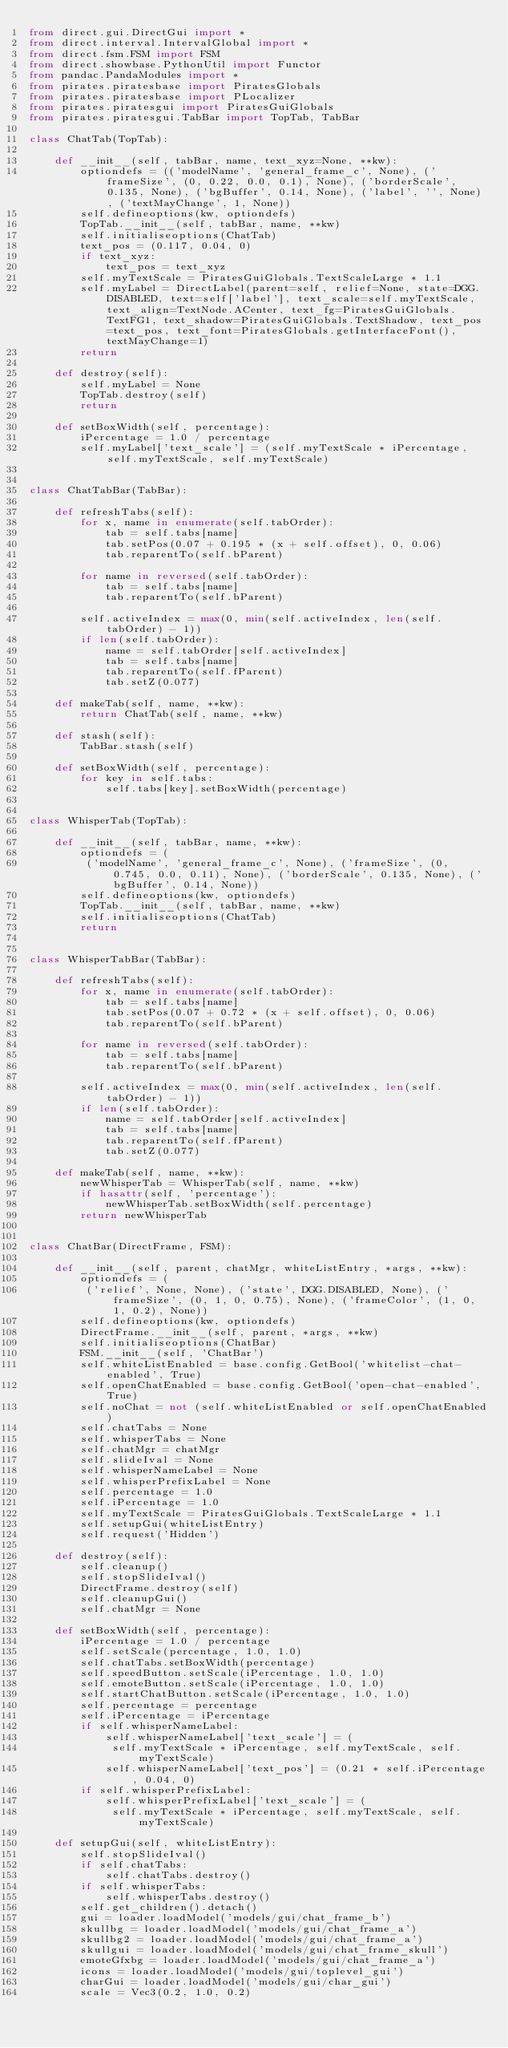<code> <loc_0><loc_0><loc_500><loc_500><_Python_>from direct.gui.DirectGui import *
from direct.interval.IntervalGlobal import *
from direct.fsm.FSM import FSM
from direct.showbase.PythonUtil import Functor
from pandac.PandaModules import *
from pirates.piratesbase import PiratesGlobals
from pirates.piratesbase import PLocalizer
from pirates.piratesgui import PiratesGuiGlobals
from pirates.piratesgui.TabBar import TopTab, TabBar

class ChatTab(TopTab):

    def __init__(self, tabBar, name, text_xyz=None, **kw):
        optiondefs = (('modelName', 'general_frame_c', None), ('frameSize', (0, 0.22, 0.0, 0.1), None), ('borderScale', 0.135, None), ('bgBuffer', 0.14, None), ('label', '', None), ('textMayChange', 1, None))
        self.defineoptions(kw, optiondefs)
        TopTab.__init__(self, tabBar, name, **kw)
        self.initialiseoptions(ChatTab)
        text_pos = (0.117, 0.04, 0)
        if text_xyz:
            text_pos = text_xyz
        self.myTextScale = PiratesGuiGlobals.TextScaleLarge * 1.1
        self.myLabel = DirectLabel(parent=self, relief=None, state=DGG.DISABLED, text=self['label'], text_scale=self.myTextScale, text_align=TextNode.ACenter, text_fg=PiratesGuiGlobals.TextFG1, text_shadow=PiratesGuiGlobals.TextShadow, text_pos=text_pos, text_font=PiratesGlobals.getInterfaceFont(), textMayChange=1)
        return

    def destroy(self):
        self.myLabel = None
        TopTab.destroy(self)
        return

    def setBoxWidth(self, percentage):
        iPercentage = 1.0 / percentage
        self.myLabel['text_scale'] = (self.myTextScale * iPercentage, self.myTextScale, self.myTextScale)


class ChatTabBar(TabBar):

    def refreshTabs(self):
        for x, name in enumerate(self.tabOrder):
            tab = self.tabs[name]
            tab.setPos(0.07 + 0.195 * (x + self.offset), 0, 0.06)
            tab.reparentTo(self.bParent)

        for name in reversed(self.tabOrder):
            tab = self.tabs[name]
            tab.reparentTo(self.bParent)

        self.activeIndex = max(0, min(self.activeIndex, len(self.tabOrder) - 1))
        if len(self.tabOrder):
            name = self.tabOrder[self.activeIndex]
            tab = self.tabs[name]
            tab.reparentTo(self.fParent)
            tab.setZ(0.077)

    def makeTab(self, name, **kw):
        return ChatTab(self, name, **kw)

    def stash(self):
        TabBar.stash(self)

    def setBoxWidth(self, percentage):
        for key in self.tabs:
            self.tabs[key].setBoxWidth(percentage)


class WhisperTab(TopTab):

    def __init__(self, tabBar, name, **kw):
        optiondefs = (
         ('modelName', 'general_frame_c', None), ('frameSize', (0, 0.745, 0.0, 0.11), None), ('borderScale', 0.135, None), ('bgBuffer', 0.14, None))
        self.defineoptions(kw, optiondefs)
        TopTab.__init__(self, tabBar, name, **kw)
        self.initialiseoptions(ChatTab)
        return


class WhisperTabBar(TabBar):

    def refreshTabs(self):
        for x, name in enumerate(self.tabOrder):
            tab = self.tabs[name]
            tab.setPos(0.07 + 0.72 * (x + self.offset), 0, 0.06)
            tab.reparentTo(self.bParent)

        for name in reversed(self.tabOrder):
            tab = self.tabs[name]
            tab.reparentTo(self.bParent)

        self.activeIndex = max(0, min(self.activeIndex, len(self.tabOrder) - 1))
        if len(self.tabOrder):
            name = self.tabOrder[self.activeIndex]
            tab = self.tabs[name]
            tab.reparentTo(self.fParent)
            tab.setZ(0.077)

    def makeTab(self, name, **kw):
        newWhisperTab = WhisperTab(self, name, **kw)
        if hasattr(self, 'percentage'):
            newWhisperTab.setBoxWidth(self.percentage)
        return newWhisperTab


class ChatBar(DirectFrame, FSM):

    def __init__(self, parent, chatMgr, whiteListEntry, *args, **kw):
        optiondefs = (
         ('relief', None, None), ('state', DGG.DISABLED, None), ('frameSize', (0, 1, 0, 0.75), None), ('frameColor', (1, 0, 1, 0.2), None))
        self.defineoptions(kw, optiondefs)
        DirectFrame.__init__(self, parent, *args, **kw)
        self.initialiseoptions(ChatBar)
        FSM.__init__(self, 'ChatBar')
        self.whiteListEnabled = base.config.GetBool('whitelist-chat-enabled', True)
        self.openChatEnabled = base.config.GetBool('open-chat-enabled', True)
        self.noChat = not (self.whiteListEnabled or self.openChatEnabled)
        self.chatTabs = None
        self.whisperTabs = None
        self.chatMgr = chatMgr
        self.slideIval = None
        self.whisperNameLabel = None
        self.whisperPrefixLabel = None
        self.percentage = 1.0
        self.iPercentage = 1.0
        self.myTextScale = PiratesGuiGlobals.TextScaleLarge * 1.1
        self.setupGui(whiteListEntry)
        self.request('Hidden')

    def destroy(self):
        self.cleanup()
        self.stopSlideIval()
        DirectFrame.destroy(self)
        self.cleanupGui()
        self.chatMgr = None

    def setBoxWidth(self, percentage):
        iPercentage = 1.0 / percentage
        self.setScale(percentage, 1.0, 1.0)
        self.chatTabs.setBoxWidth(percentage)
        self.speedButton.setScale(iPercentage, 1.0, 1.0)
        self.emoteButton.setScale(iPercentage, 1.0, 1.0)
        self.startChatButton.setScale(iPercentage, 1.0, 1.0)
        self.percentage = percentage
        self.iPercentage = iPercentage
        if self.whisperNameLabel:
            self.whisperNameLabel['text_scale'] = (
             self.myTextScale * iPercentage, self.myTextScale, self.myTextScale)
            self.whisperNameLabel['text_pos'] = (0.21 * self.iPercentage, 0.04, 0)
        if self.whisperPrefixLabel:
            self.whisperPrefixLabel['text_scale'] = (
             self.myTextScale * iPercentage, self.myTextScale, self.myTextScale)

    def setupGui(self, whiteListEntry):
        self.stopSlideIval()
        if self.chatTabs:
            self.chatTabs.destroy()
        if self.whisperTabs:
            self.whisperTabs.destroy()
        self.get_children().detach()
        gui = loader.loadModel('models/gui/chat_frame_b')
        skullbg = loader.loadModel('models/gui/chat_frame_a')
        skullbg2 = loader.loadModel('models/gui/chat_frame_a')
        skullgui = loader.loadModel('models/gui/chat_frame_skull')
        emoteGfxbg = loader.loadModel('models/gui/chat_frame_a')
        icons = loader.loadModel('models/gui/toplevel_gui')
        charGui = loader.loadModel('models/gui/char_gui')
        scale = Vec3(0.2, 1.0, 0.2)</code> 